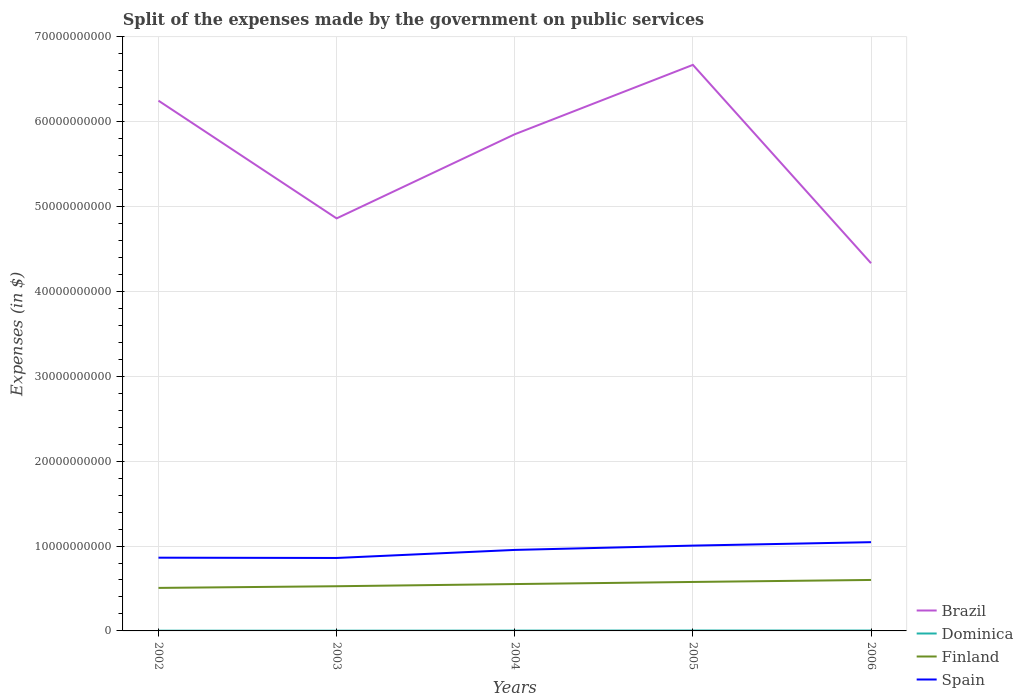How many different coloured lines are there?
Offer a very short reply. 4. Does the line corresponding to Spain intersect with the line corresponding to Brazil?
Your answer should be very brief. No. Across all years, what is the maximum expenses made by the government on public services in Brazil?
Make the answer very short. 4.33e+1. In which year was the expenses made by the government on public services in Finland maximum?
Offer a very short reply. 2002. What is the total expenses made by the government on public services in Dominica in the graph?
Make the answer very short. -8.40e+06. What is the difference between the highest and the second highest expenses made by the government on public services in Dominica?
Offer a terse response. 2.04e+07. Is the expenses made by the government on public services in Dominica strictly greater than the expenses made by the government on public services in Finland over the years?
Your answer should be compact. Yes. How many lines are there?
Offer a terse response. 4. Are the values on the major ticks of Y-axis written in scientific E-notation?
Keep it short and to the point. No. Does the graph contain any zero values?
Keep it short and to the point. No. Does the graph contain grids?
Offer a very short reply. Yes. How many legend labels are there?
Offer a terse response. 4. What is the title of the graph?
Your answer should be very brief. Split of the expenses made by the government on public services. What is the label or title of the X-axis?
Offer a terse response. Years. What is the label or title of the Y-axis?
Offer a terse response. Expenses (in $). What is the Expenses (in $) in Brazil in 2002?
Provide a short and direct response. 6.25e+1. What is the Expenses (in $) in Dominica in 2002?
Your answer should be very brief. 3.00e+07. What is the Expenses (in $) in Finland in 2002?
Your answer should be very brief. 5.07e+09. What is the Expenses (in $) in Spain in 2002?
Offer a very short reply. 8.63e+09. What is the Expenses (in $) of Brazil in 2003?
Give a very brief answer. 4.86e+1. What is the Expenses (in $) of Dominica in 2003?
Your response must be concise. 2.96e+07. What is the Expenses (in $) of Finland in 2003?
Ensure brevity in your answer.  5.26e+09. What is the Expenses (in $) of Spain in 2003?
Provide a short and direct response. 8.60e+09. What is the Expenses (in $) of Brazil in 2004?
Provide a short and direct response. 5.85e+1. What is the Expenses (in $) of Dominica in 2004?
Make the answer very short. 3.83e+07. What is the Expenses (in $) of Finland in 2004?
Your response must be concise. 5.52e+09. What is the Expenses (in $) of Spain in 2004?
Offer a very short reply. 9.54e+09. What is the Expenses (in $) of Brazil in 2005?
Provide a short and direct response. 6.67e+1. What is the Expenses (in $) of Finland in 2005?
Provide a succinct answer. 5.77e+09. What is the Expenses (in $) of Spain in 2005?
Offer a terse response. 1.01e+1. What is the Expenses (in $) of Brazil in 2006?
Offer a terse response. 4.33e+1. What is the Expenses (in $) of Dominica in 2006?
Offer a very short reply. 4.67e+07. What is the Expenses (in $) of Finland in 2006?
Provide a succinct answer. 6.00e+09. What is the Expenses (in $) of Spain in 2006?
Offer a terse response. 1.05e+1. Across all years, what is the maximum Expenses (in $) in Brazil?
Your response must be concise. 6.67e+1. Across all years, what is the maximum Expenses (in $) in Dominica?
Make the answer very short. 5.00e+07. Across all years, what is the maximum Expenses (in $) of Finland?
Offer a very short reply. 6.00e+09. Across all years, what is the maximum Expenses (in $) in Spain?
Provide a succinct answer. 1.05e+1. Across all years, what is the minimum Expenses (in $) in Brazil?
Provide a succinct answer. 4.33e+1. Across all years, what is the minimum Expenses (in $) of Dominica?
Your answer should be very brief. 2.96e+07. Across all years, what is the minimum Expenses (in $) of Finland?
Your answer should be compact. 5.07e+09. Across all years, what is the minimum Expenses (in $) in Spain?
Your answer should be compact. 8.60e+09. What is the total Expenses (in $) of Brazil in the graph?
Offer a very short reply. 2.80e+11. What is the total Expenses (in $) of Dominica in the graph?
Offer a terse response. 1.95e+08. What is the total Expenses (in $) of Finland in the graph?
Your answer should be compact. 2.76e+1. What is the total Expenses (in $) of Spain in the graph?
Provide a succinct answer. 4.73e+1. What is the difference between the Expenses (in $) in Brazil in 2002 and that in 2003?
Ensure brevity in your answer.  1.39e+1. What is the difference between the Expenses (in $) in Finland in 2002 and that in 2003?
Your answer should be compact. -1.97e+08. What is the difference between the Expenses (in $) in Spain in 2002 and that in 2003?
Give a very brief answer. 3.20e+07. What is the difference between the Expenses (in $) of Brazil in 2002 and that in 2004?
Offer a very short reply. 3.96e+09. What is the difference between the Expenses (in $) of Dominica in 2002 and that in 2004?
Offer a very short reply. -8.30e+06. What is the difference between the Expenses (in $) in Finland in 2002 and that in 2004?
Provide a succinct answer. -4.53e+08. What is the difference between the Expenses (in $) in Spain in 2002 and that in 2004?
Provide a succinct answer. -9.15e+08. What is the difference between the Expenses (in $) in Brazil in 2002 and that in 2005?
Your answer should be compact. -4.22e+09. What is the difference between the Expenses (in $) of Dominica in 2002 and that in 2005?
Make the answer very short. -2.00e+07. What is the difference between the Expenses (in $) in Finland in 2002 and that in 2005?
Offer a terse response. -7.02e+08. What is the difference between the Expenses (in $) in Spain in 2002 and that in 2005?
Make the answer very short. -1.42e+09. What is the difference between the Expenses (in $) in Brazil in 2002 and that in 2006?
Provide a short and direct response. 1.92e+1. What is the difference between the Expenses (in $) of Dominica in 2002 and that in 2006?
Offer a terse response. -1.67e+07. What is the difference between the Expenses (in $) in Finland in 2002 and that in 2006?
Provide a short and direct response. -9.37e+08. What is the difference between the Expenses (in $) in Spain in 2002 and that in 2006?
Ensure brevity in your answer.  -1.83e+09. What is the difference between the Expenses (in $) of Brazil in 2003 and that in 2004?
Offer a very short reply. -9.91e+09. What is the difference between the Expenses (in $) of Dominica in 2003 and that in 2004?
Your answer should be compact. -8.70e+06. What is the difference between the Expenses (in $) of Finland in 2003 and that in 2004?
Your answer should be very brief. -2.56e+08. What is the difference between the Expenses (in $) of Spain in 2003 and that in 2004?
Provide a short and direct response. -9.47e+08. What is the difference between the Expenses (in $) in Brazil in 2003 and that in 2005?
Give a very brief answer. -1.81e+1. What is the difference between the Expenses (in $) of Dominica in 2003 and that in 2005?
Give a very brief answer. -2.04e+07. What is the difference between the Expenses (in $) of Finland in 2003 and that in 2005?
Offer a very short reply. -5.05e+08. What is the difference between the Expenses (in $) of Spain in 2003 and that in 2005?
Your answer should be compact. -1.46e+09. What is the difference between the Expenses (in $) of Brazil in 2003 and that in 2006?
Your answer should be compact. 5.28e+09. What is the difference between the Expenses (in $) in Dominica in 2003 and that in 2006?
Provide a short and direct response. -1.71e+07. What is the difference between the Expenses (in $) in Finland in 2003 and that in 2006?
Offer a terse response. -7.40e+08. What is the difference between the Expenses (in $) in Spain in 2003 and that in 2006?
Ensure brevity in your answer.  -1.86e+09. What is the difference between the Expenses (in $) in Brazil in 2004 and that in 2005?
Provide a short and direct response. -8.18e+09. What is the difference between the Expenses (in $) in Dominica in 2004 and that in 2005?
Provide a succinct answer. -1.17e+07. What is the difference between the Expenses (in $) of Finland in 2004 and that in 2005?
Your answer should be compact. -2.49e+08. What is the difference between the Expenses (in $) of Spain in 2004 and that in 2005?
Provide a short and direct response. -5.09e+08. What is the difference between the Expenses (in $) of Brazil in 2004 and that in 2006?
Your answer should be very brief. 1.52e+1. What is the difference between the Expenses (in $) in Dominica in 2004 and that in 2006?
Give a very brief answer. -8.40e+06. What is the difference between the Expenses (in $) in Finland in 2004 and that in 2006?
Offer a very short reply. -4.84e+08. What is the difference between the Expenses (in $) of Spain in 2004 and that in 2006?
Make the answer very short. -9.14e+08. What is the difference between the Expenses (in $) of Brazil in 2005 and that in 2006?
Offer a very short reply. 2.34e+1. What is the difference between the Expenses (in $) of Dominica in 2005 and that in 2006?
Offer a terse response. 3.30e+06. What is the difference between the Expenses (in $) in Finland in 2005 and that in 2006?
Your answer should be compact. -2.35e+08. What is the difference between the Expenses (in $) of Spain in 2005 and that in 2006?
Ensure brevity in your answer.  -4.05e+08. What is the difference between the Expenses (in $) in Brazil in 2002 and the Expenses (in $) in Dominica in 2003?
Offer a terse response. 6.24e+1. What is the difference between the Expenses (in $) of Brazil in 2002 and the Expenses (in $) of Finland in 2003?
Make the answer very short. 5.72e+1. What is the difference between the Expenses (in $) of Brazil in 2002 and the Expenses (in $) of Spain in 2003?
Give a very brief answer. 5.39e+1. What is the difference between the Expenses (in $) of Dominica in 2002 and the Expenses (in $) of Finland in 2003?
Ensure brevity in your answer.  -5.24e+09. What is the difference between the Expenses (in $) of Dominica in 2002 and the Expenses (in $) of Spain in 2003?
Your answer should be compact. -8.57e+09. What is the difference between the Expenses (in $) of Finland in 2002 and the Expenses (in $) of Spain in 2003?
Offer a terse response. -3.53e+09. What is the difference between the Expenses (in $) of Brazil in 2002 and the Expenses (in $) of Dominica in 2004?
Offer a very short reply. 6.24e+1. What is the difference between the Expenses (in $) of Brazil in 2002 and the Expenses (in $) of Finland in 2004?
Provide a succinct answer. 5.70e+1. What is the difference between the Expenses (in $) in Brazil in 2002 and the Expenses (in $) in Spain in 2004?
Your answer should be compact. 5.29e+1. What is the difference between the Expenses (in $) of Dominica in 2002 and the Expenses (in $) of Finland in 2004?
Your response must be concise. -5.49e+09. What is the difference between the Expenses (in $) of Dominica in 2002 and the Expenses (in $) of Spain in 2004?
Make the answer very short. -9.51e+09. What is the difference between the Expenses (in $) in Finland in 2002 and the Expenses (in $) in Spain in 2004?
Make the answer very short. -4.48e+09. What is the difference between the Expenses (in $) in Brazil in 2002 and the Expenses (in $) in Dominica in 2005?
Offer a very short reply. 6.24e+1. What is the difference between the Expenses (in $) of Brazil in 2002 and the Expenses (in $) of Finland in 2005?
Keep it short and to the point. 5.67e+1. What is the difference between the Expenses (in $) in Brazil in 2002 and the Expenses (in $) in Spain in 2005?
Make the answer very short. 5.24e+1. What is the difference between the Expenses (in $) of Dominica in 2002 and the Expenses (in $) of Finland in 2005?
Provide a succinct answer. -5.74e+09. What is the difference between the Expenses (in $) of Dominica in 2002 and the Expenses (in $) of Spain in 2005?
Your answer should be very brief. -1.00e+1. What is the difference between the Expenses (in $) of Finland in 2002 and the Expenses (in $) of Spain in 2005?
Offer a very short reply. -4.98e+09. What is the difference between the Expenses (in $) in Brazil in 2002 and the Expenses (in $) in Dominica in 2006?
Your answer should be very brief. 6.24e+1. What is the difference between the Expenses (in $) in Brazil in 2002 and the Expenses (in $) in Finland in 2006?
Offer a terse response. 5.65e+1. What is the difference between the Expenses (in $) in Brazil in 2002 and the Expenses (in $) in Spain in 2006?
Provide a short and direct response. 5.20e+1. What is the difference between the Expenses (in $) in Dominica in 2002 and the Expenses (in $) in Finland in 2006?
Keep it short and to the point. -5.98e+09. What is the difference between the Expenses (in $) of Dominica in 2002 and the Expenses (in $) of Spain in 2006?
Your answer should be very brief. -1.04e+1. What is the difference between the Expenses (in $) in Finland in 2002 and the Expenses (in $) in Spain in 2006?
Keep it short and to the point. -5.39e+09. What is the difference between the Expenses (in $) of Brazil in 2003 and the Expenses (in $) of Dominica in 2004?
Provide a short and direct response. 4.86e+1. What is the difference between the Expenses (in $) of Brazil in 2003 and the Expenses (in $) of Finland in 2004?
Provide a short and direct response. 4.31e+1. What is the difference between the Expenses (in $) of Brazil in 2003 and the Expenses (in $) of Spain in 2004?
Ensure brevity in your answer.  3.91e+1. What is the difference between the Expenses (in $) of Dominica in 2003 and the Expenses (in $) of Finland in 2004?
Keep it short and to the point. -5.49e+09. What is the difference between the Expenses (in $) of Dominica in 2003 and the Expenses (in $) of Spain in 2004?
Provide a short and direct response. -9.51e+09. What is the difference between the Expenses (in $) in Finland in 2003 and the Expenses (in $) in Spain in 2004?
Ensure brevity in your answer.  -4.28e+09. What is the difference between the Expenses (in $) of Brazil in 2003 and the Expenses (in $) of Dominica in 2005?
Your answer should be very brief. 4.86e+1. What is the difference between the Expenses (in $) of Brazil in 2003 and the Expenses (in $) of Finland in 2005?
Offer a terse response. 4.28e+1. What is the difference between the Expenses (in $) in Brazil in 2003 and the Expenses (in $) in Spain in 2005?
Offer a very short reply. 3.86e+1. What is the difference between the Expenses (in $) of Dominica in 2003 and the Expenses (in $) of Finland in 2005?
Keep it short and to the point. -5.74e+09. What is the difference between the Expenses (in $) in Dominica in 2003 and the Expenses (in $) in Spain in 2005?
Ensure brevity in your answer.  -1.00e+1. What is the difference between the Expenses (in $) of Finland in 2003 and the Expenses (in $) of Spain in 2005?
Make the answer very short. -4.79e+09. What is the difference between the Expenses (in $) in Brazil in 2003 and the Expenses (in $) in Dominica in 2006?
Your response must be concise. 4.86e+1. What is the difference between the Expenses (in $) of Brazil in 2003 and the Expenses (in $) of Finland in 2006?
Offer a very short reply. 4.26e+1. What is the difference between the Expenses (in $) in Brazil in 2003 and the Expenses (in $) in Spain in 2006?
Your answer should be very brief. 3.81e+1. What is the difference between the Expenses (in $) of Dominica in 2003 and the Expenses (in $) of Finland in 2006?
Provide a short and direct response. -5.98e+09. What is the difference between the Expenses (in $) of Dominica in 2003 and the Expenses (in $) of Spain in 2006?
Give a very brief answer. -1.04e+1. What is the difference between the Expenses (in $) in Finland in 2003 and the Expenses (in $) in Spain in 2006?
Your answer should be very brief. -5.19e+09. What is the difference between the Expenses (in $) in Brazil in 2004 and the Expenses (in $) in Dominica in 2005?
Provide a short and direct response. 5.85e+1. What is the difference between the Expenses (in $) of Brazil in 2004 and the Expenses (in $) of Finland in 2005?
Make the answer very short. 5.27e+1. What is the difference between the Expenses (in $) of Brazil in 2004 and the Expenses (in $) of Spain in 2005?
Keep it short and to the point. 4.85e+1. What is the difference between the Expenses (in $) of Dominica in 2004 and the Expenses (in $) of Finland in 2005?
Your response must be concise. -5.73e+09. What is the difference between the Expenses (in $) in Dominica in 2004 and the Expenses (in $) in Spain in 2005?
Keep it short and to the point. -1.00e+1. What is the difference between the Expenses (in $) in Finland in 2004 and the Expenses (in $) in Spain in 2005?
Offer a very short reply. -4.53e+09. What is the difference between the Expenses (in $) of Brazil in 2004 and the Expenses (in $) of Dominica in 2006?
Make the answer very short. 5.85e+1. What is the difference between the Expenses (in $) of Brazil in 2004 and the Expenses (in $) of Finland in 2006?
Provide a short and direct response. 5.25e+1. What is the difference between the Expenses (in $) of Brazil in 2004 and the Expenses (in $) of Spain in 2006?
Your answer should be compact. 4.81e+1. What is the difference between the Expenses (in $) of Dominica in 2004 and the Expenses (in $) of Finland in 2006?
Your answer should be very brief. -5.97e+09. What is the difference between the Expenses (in $) in Dominica in 2004 and the Expenses (in $) in Spain in 2006?
Offer a very short reply. -1.04e+1. What is the difference between the Expenses (in $) in Finland in 2004 and the Expenses (in $) in Spain in 2006?
Offer a terse response. -4.94e+09. What is the difference between the Expenses (in $) of Brazil in 2005 and the Expenses (in $) of Dominica in 2006?
Your response must be concise. 6.66e+1. What is the difference between the Expenses (in $) of Brazil in 2005 and the Expenses (in $) of Finland in 2006?
Give a very brief answer. 6.07e+1. What is the difference between the Expenses (in $) in Brazil in 2005 and the Expenses (in $) in Spain in 2006?
Your answer should be very brief. 5.62e+1. What is the difference between the Expenses (in $) in Dominica in 2005 and the Expenses (in $) in Finland in 2006?
Your answer should be compact. -5.96e+09. What is the difference between the Expenses (in $) of Dominica in 2005 and the Expenses (in $) of Spain in 2006?
Offer a very short reply. -1.04e+1. What is the difference between the Expenses (in $) of Finland in 2005 and the Expenses (in $) of Spain in 2006?
Your answer should be compact. -4.69e+09. What is the average Expenses (in $) of Brazil per year?
Make the answer very short. 5.59e+1. What is the average Expenses (in $) of Dominica per year?
Give a very brief answer. 3.89e+07. What is the average Expenses (in $) of Finland per year?
Offer a very short reply. 5.53e+09. What is the average Expenses (in $) in Spain per year?
Your response must be concise. 9.46e+09. In the year 2002, what is the difference between the Expenses (in $) of Brazil and Expenses (in $) of Dominica?
Make the answer very short. 6.24e+1. In the year 2002, what is the difference between the Expenses (in $) of Brazil and Expenses (in $) of Finland?
Ensure brevity in your answer.  5.74e+1. In the year 2002, what is the difference between the Expenses (in $) of Brazil and Expenses (in $) of Spain?
Offer a terse response. 5.38e+1. In the year 2002, what is the difference between the Expenses (in $) in Dominica and Expenses (in $) in Finland?
Keep it short and to the point. -5.04e+09. In the year 2002, what is the difference between the Expenses (in $) of Dominica and Expenses (in $) of Spain?
Provide a succinct answer. -8.60e+09. In the year 2002, what is the difference between the Expenses (in $) of Finland and Expenses (in $) of Spain?
Your answer should be compact. -3.56e+09. In the year 2003, what is the difference between the Expenses (in $) in Brazil and Expenses (in $) in Dominica?
Offer a very short reply. 4.86e+1. In the year 2003, what is the difference between the Expenses (in $) of Brazil and Expenses (in $) of Finland?
Make the answer very short. 4.33e+1. In the year 2003, what is the difference between the Expenses (in $) of Brazil and Expenses (in $) of Spain?
Give a very brief answer. 4.00e+1. In the year 2003, what is the difference between the Expenses (in $) in Dominica and Expenses (in $) in Finland?
Make the answer very short. -5.24e+09. In the year 2003, what is the difference between the Expenses (in $) in Dominica and Expenses (in $) in Spain?
Make the answer very short. -8.57e+09. In the year 2003, what is the difference between the Expenses (in $) in Finland and Expenses (in $) in Spain?
Give a very brief answer. -3.33e+09. In the year 2004, what is the difference between the Expenses (in $) in Brazil and Expenses (in $) in Dominica?
Keep it short and to the point. 5.85e+1. In the year 2004, what is the difference between the Expenses (in $) in Brazil and Expenses (in $) in Finland?
Your answer should be compact. 5.30e+1. In the year 2004, what is the difference between the Expenses (in $) in Brazil and Expenses (in $) in Spain?
Keep it short and to the point. 4.90e+1. In the year 2004, what is the difference between the Expenses (in $) in Dominica and Expenses (in $) in Finland?
Provide a short and direct response. -5.48e+09. In the year 2004, what is the difference between the Expenses (in $) in Dominica and Expenses (in $) in Spain?
Your answer should be very brief. -9.50e+09. In the year 2004, what is the difference between the Expenses (in $) in Finland and Expenses (in $) in Spain?
Ensure brevity in your answer.  -4.02e+09. In the year 2005, what is the difference between the Expenses (in $) in Brazil and Expenses (in $) in Dominica?
Your answer should be compact. 6.66e+1. In the year 2005, what is the difference between the Expenses (in $) in Brazil and Expenses (in $) in Finland?
Your response must be concise. 6.09e+1. In the year 2005, what is the difference between the Expenses (in $) of Brazil and Expenses (in $) of Spain?
Provide a succinct answer. 5.66e+1. In the year 2005, what is the difference between the Expenses (in $) in Dominica and Expenses (in $) in Finland?
Your answer should be very brief. -5.72e+09. In the year 2005, what is the difference between the Expenses (in $) in Dominica and Expenses (in $) in Spain?
Ensure brevity in your answer.  -1.00e+1. In the year 2005, what is the difference between the Expenses (in $) of Finland and Expenses (in $) of Spain?
Keep it short and to the point. -4.28e+09. In the year 2006, what is the difference between the Expenses (in $) in Brazil and Expenses (in $) in Dominica?
Give a very brief answer. 4.33e+1. In the year 2006, what is the difference between the Expenses (in $) in Brazil and Expenses (in $) in Finland?
Your answer should be compact. 3.73e+1. In the year 2006, what is the difference between the Expenses (in $) in Brazil and Expenses (in $) in Spain?
Give a very brief answer. 3.29e+1. In the year 2006, what is the difference between the Expenses (in $) of Dominica and Expenses (in $) of Finland?
Offer a terse response. -5.96e+09. In the year 2006, what is the difference between the Expenses (in $) in Dominica and Expenses (in $) in Spain?
Keep it short and to the point. -1.04e+1. In the year 2006, what is the difference between the Expenses (in $) of Finland and Expenses (in $) of Spain?
Offer a very short reply. -4.45e+09. What is the ratio of the Expenses (in $) of Brazil in 2002 to that in 2003?
Your response must be concise. 1.29. What is the ratio of the Expenses (in $) of Dominica in 2002 to that in 2003?
Make the answer very short. 1.01. What is the ratio of the Expenses (in $) in Finland in 2002 to that in 2003?
Give a very brief answer. 0.96. What is the ratio of the Expenses (in $) of Brazil in 2002 to that in 2004?
Provide a succinct answer. 1.07. What is the ratio of the Expenses (in $) in Dominica in 2002 to that in 2004?
Give a very brief answer. 0.78. What is the ratio of the Expenses (in $) of Finland in 2002 to that in 2004?
Provide a short and direct response. 0.92. What is the ratio of the Expenses (in $) in Spain in 2002 to that in 2004?
Ensure brevity in your answer.  0.9. What is the ratio of the Expenses (in $) of Brazil in 2002 to that in 2005?
Give a very brief answer. 0.94. What is the ratio of the Expenses (in $) of Finland in 2002 to that in 2005?
Provide a succinct answer. 0.88. What is the ratio of the Expenses (in $) of Spain in 2002 to that in 2005?
Ensure brevity in your answer.  0.86. What is the ratio of the Expenses (in $) in Brazil in 2002 to that in 2006?
Offer a terse response. 1.44. What is the ratio of the Expenses (in $) in Dominica in 2002 to that in 2006?
Make the answer very short. 0.64. What is the ratio of the Expenses (in $) in Finland in 2002 to that in 2006?
Provide a succinct answer. 0.84. What is the ratio of the Expenses (in $) of Spain in 2002 to that in 2006?
Your answer should be compact. 0.83. What is the ratio of the Expenses (in $) in Brazil in 2003 to that in 2004?
Keep it short and to the point. 0.83. What is the ratio of the Expenses (in $) in Dominica in 2003 to that in 2004?
Keep it short and to the point. 0.77. What is the ratio of the Expenses (in $) in Finland in 2003 to that in 2004?
Offer a very short reply. 0.95. What is the ratio of the Expenses (in $) in Spain in 2003 to that in 2004?
Provide a short and direct response. 0.9. What is the ratio of the Expenses (in $) of Brazil in 2003 to that in 2005?
Provide a short and direct response. 0.73. What is the ratio of the Expenses (in $) of Dominica in 2003 to that in 2005?
Give a very brief answer. 0.59. What is the ratio of the Expenses (in $) in Finland in 2003 to that in 2005?
Your answer should be very brief. 0.91. What is the ratio of the Expenses (in $) of Spain in 2003 to that in 2005?
Your response must be concise. 0.86. What is the ratio of the Expenses (in $) of Brazil in 2003 to that in 2006?
Give a very brief answer. 1.12. What is the ratio of the Expenses (in $) in Dominica in 2003 to that in 2006?
Give a very brief answer. 0.63. What is the ratio of the Expenses (in $) of Finland in 2003 to that in 2006?
Your answer should be very brief. 0.88. What is the ratio of the Expenses (in $) in Spain in 2003 to that in 2006?
Give a very brief answer. 0.82. What is the ratio of the Expenses (in $) of Brazil in 2004 to that in 2005?
Your answer should be compact. 0.88. What is the ratio of the Expenses (in $) in Dominica in 2004 to that in 2005?
Keep it short and to the point. 0.77. What is the ratio of the Expenses (in $) in Finland in 2004 to that in 2005?
Your answer should be compact. 0.96. What is the ratio of the Expenses (in $) of Spain in 2004 to that in 2005?
Offer a terse response. 0.95. What is the ratio of the Expenses (in $) in Brazil in 2004 to that in 2006?
Your answer should be compact. 1.35. What is the ratio of the Expenses (in $) in Dominica in 2004 to that in 2006?
Your answer should be very brief. 0.82. What is the ratio of the Expenses (in $) in Finland in 2004 to that in 2006?
Offer a very short reply. 0.92. What is the ratio of the Expenses (in $) of Spain in 2004 to that in 2006?
Keep it short and to the point. 0.91. What is the ratio of the Expenses (in $) in Brazil in 2005 to that in 2006?
Your answer should be compact. 1.54. What is the ratio of the Expenses (in $) in Dominica in 2005 to that in 2006?
Your answer should be very brief. 1.07. What is the ratio of the Expenses (in $) of Finland in 2005 to that in 2006?
Your answer should be very brief. 0.96. What is the ratio of the Expenses (in $) of Spain in 2005 to that in 2006?
Your response must be concise. 0.96. What is the difference between the highest and the second highest Expenses (in $) in Brazil?
Offer a terse response. 4.22e+09. What is the difference between the highest and the second highest Expenses (in $) in Dominica?
Keep it short and to the point. 3.30e+06. What is the difference between the highest and the second highest Expenses (in $) of Finland?
Keep it short and to the point. 2.35e+08. What is the difference between the highest and the second highest Expenses (in $) in Spain?
Your answer should be compact. 4.05e+08. What is the difference between the highest and the lowest Expenses (in $) of Brazil?
Keep it short and to the point. 2.34e+1. What is the difference between the highest and the lowest Expenses (in $) in Dominica?
Make the answer very short. 2.04e+07. What is the difference between the highest and the lowest Expenses (in $) of Finland?
Your answer should be very brief. 9.37e+08. What is the difference between the highest and the lowest Expenses (in $) of Spain?
Give a very brief answer. 1.86e+09. 